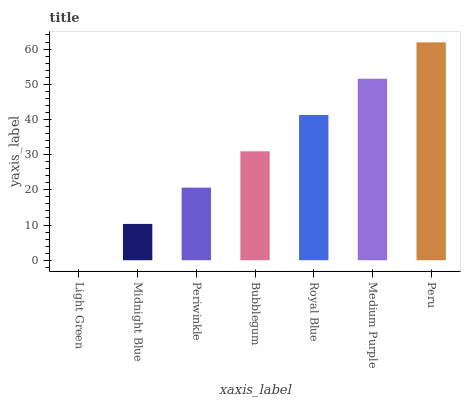Is Light Green the minimum?
Answer yes or no. Yes. Is Peru the maximum?
Answer yes or no. Yes. Is Midnight Blue the minimum?
Answer yes or no. No. Is Midnight Blue the maximum?
Answer yes or no. No. Is Midnight Blue greater than Light Green?
Answer yes or no. Yes. Is Light Green less than Midnight Blue?
Answer yes or no. Yes. Is Light Green greater than Midnight Blue?
Answer yes or no. No. Is Midnight Blue less than Light Green?
Answer yes or no. No. Is Bubblegum the high median?
Answer yes or no. Yes. Is Bubblegum the low median?
Answer yes or no. Yes. Is Medium Purple the high median?
Answer yes or no. No. Is Medium Purple the low median?
Answer yes or no. No. 